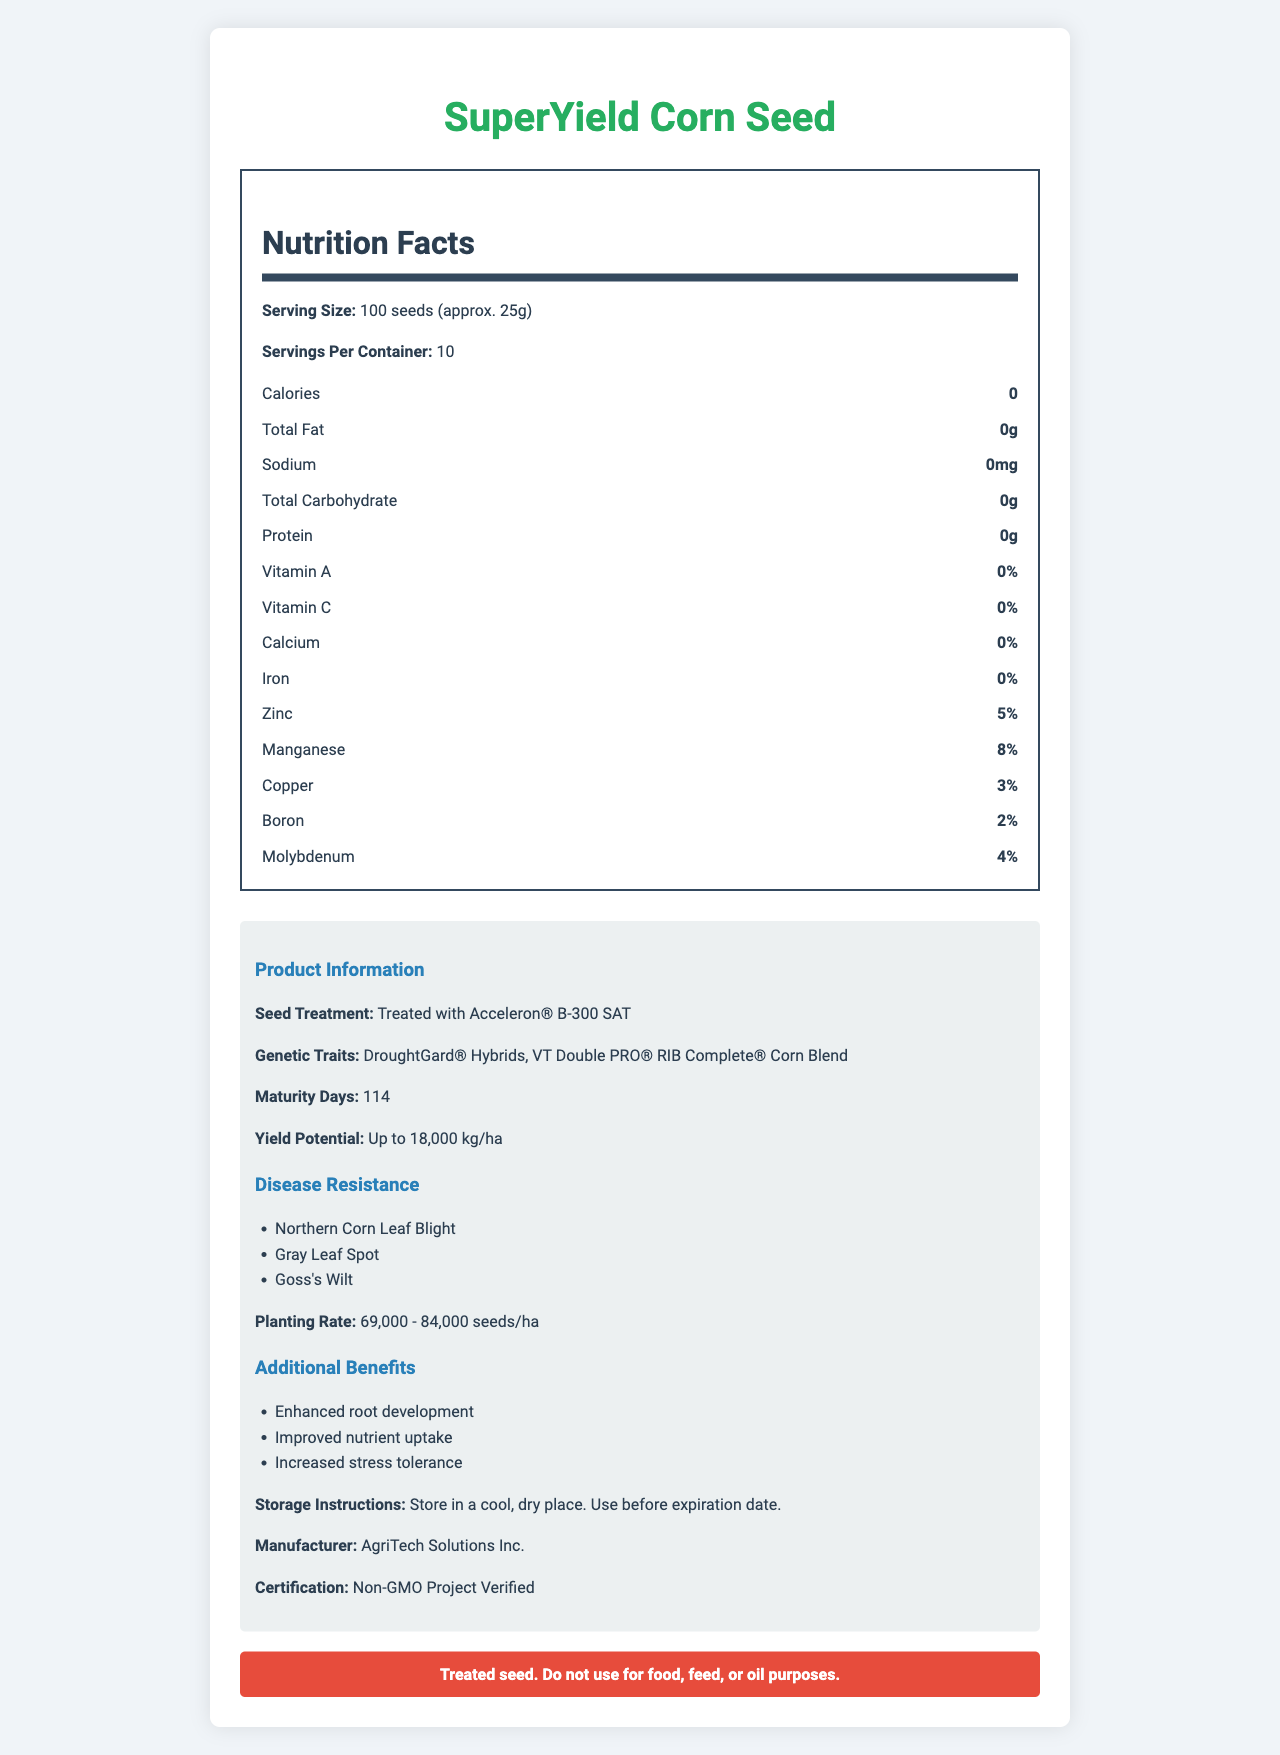what is the serving size for SuperYield Corn Seed? The serving size is listed at the beginning of the nutrition facts section.
Answer: 100 seeds (approx. 25g) how many servings are there per container? The number of servings per container is stated right after the serving size.
Answer: 10 how much zinc is in the SuperYield Corn Seed? The percentage of zinc is shown in the nutrition facts under the mineral section.
Answer: 5% how long does it take for SuperYield Corn to mature? The maturity days are mentioned in the product information section.
Answer: 114 days what is the planting rate for SuperYield Corn Seed? The planting rate can be found in the product information section.
Answer: 69,000 - 84,000 seeds/ha which of the following diseases is SuperYield Corn Seed resistant to? A. Northern Corn Leaf Blight B. Southern Rust C. Anthracnose Northern Corn Leaf Blight is listed under disease resistance.
Answer: A what certification does the SuperYield Corn Seed have? A. USDA Organic B. Non-GMO Project Verified C. Fair Trade The certification is stated as Non-GMO Project Verified in the product information.
Answer: B which genetic trait includes protection against drought? A. VT Double PRO® RIB Complete® B. DroughtGard® Hybrids C. SmartStax® DroughtGard® Hybrids specifically mention drought in the genetic traits section.
Answer: B is the seed treated for enhanced performance? The seed treatment is highlighted as "Treated with Acceleron® B-300 SAT" in the product information section.
Answer: Yes does the document provide information on the seed's nitrogen content? There's no mention of nitrogen in the nutrition facts or product information.
Answer: No what is the yield potential for SuperYield Corn Seed? The yield potential is indicated in the product information section.
Answer: Up to 18,000 kg/ha describe the key features of the SuperYield Corn Seed. The document encompasses nutritional facts, genetic traits, treatment information, yield potential, disease resistance, planting rate, additional benefits, storage instructions, manufacturer details, and a warning about the seed treatment.
Answer: The SuperYield Corn Seed is genetically modified to improve yield, drought resistance, and disease resistance. It includes genetic traits such as DroughtGard® Hybrids and VT Double PRO® RIB Complete® Corn Blend. The seed has several essential minerals, is treated with Acceleron®, and offers enhanced root development, improved nutrient uptake, and increased stress tolerance. It is verified as Non-GMO, should be stored in a cool, dry place, and comes with specific planting rates and maturity days. which company manufactures SuperYield Corn Seed? The manufacturer information is provided towards the end of the product information section.
Answer: AgriTech Solutions Inc. can the SuperYield Corn Seed be used for oil purposes? There is a clear warning at the end of the document stating that the treated seed should not be used for food, feed, or oil purposes.
Answer: No what are the additional benefits of this seed? These benefits are listed under additional information in the product details section.
Answer: Enhanced root development, improved nutrient uptake, increased stress tolerance 